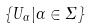Convert formula to latex. <formula><loc_0><loc_0><loc_500><loc_500>\{ U _ { \alpha } | \alpha \in \Sigma \}</formula> 